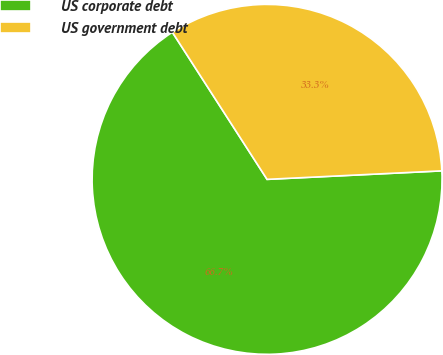Convert chart. <chart><loc_0><loc_0><loc_500><loc_500><pie_chart><fcel>US corporate debt<fcel>US government debt<nl><fcel>66.67%<fcel>33.33%<nl></chart> 